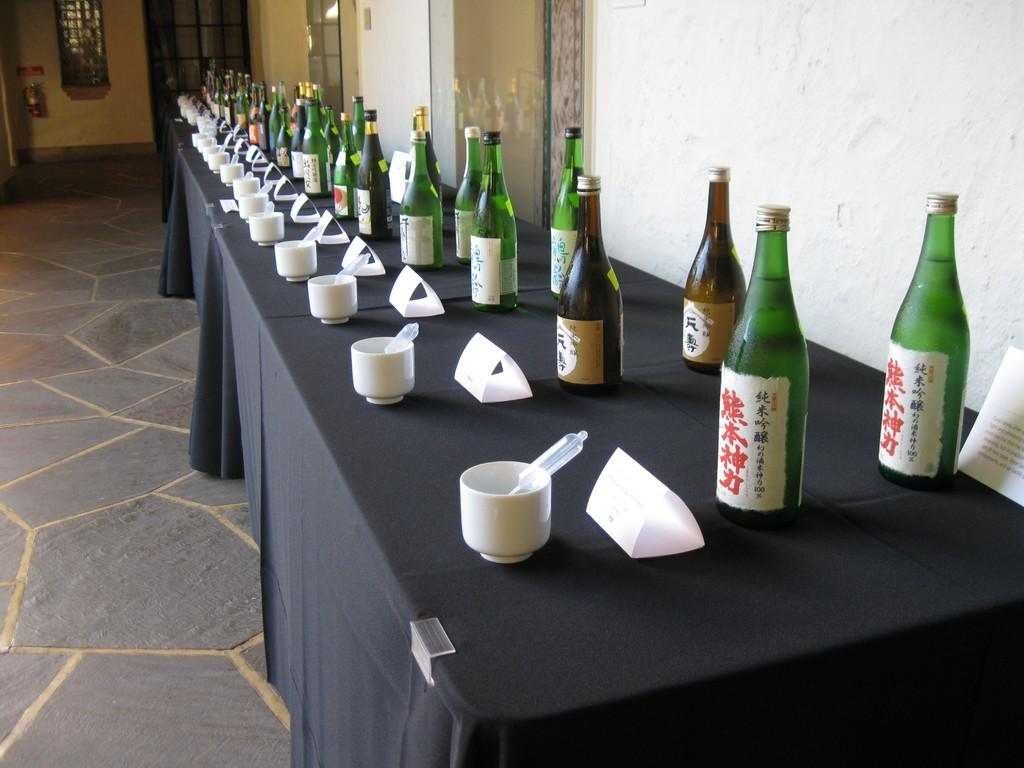What type of furniture is present in the image? There is a table in the image. What items can be seen on the table? There are wine bottles, cups, and papers on the table. Can you hear the acoustics of the kitten meowing in the image? There is no kitten present in the image, and therefore no sound or acoustics can be heard. 